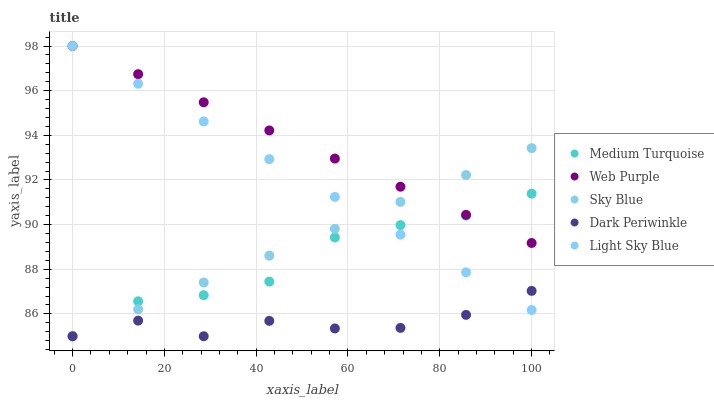Does Dark Periwinkle have the minimum area under the curve?
Answer yes or no. Yes. Does Web Purple have the maximum area under the curve?
Answer yes or no. Yes. Does Light Sky Blue have the minimum area under the curve?
Answer yes or no. No. Does Light Sky Blue have the maximum area under the curve?
Answer yes or no. No. Is Light Sky Blue the smoothest?
Answer yes or no. Yes. Is Dark Periwinkle the roughest?
Answer yes or no. Yes. Is Web Purple the smoothest?
Answer yes or no. No. Is Web Purple the roughest?
Answer yes or no. No. Does Sky Blue have the lowest value?
Answer yes or no. Yes. Does Light Sky Blue have the lowest value?
Answer yes or no. No. Does Light Sky Blue have the highest value?
Answer yes or no. Yes. Does Dark Periwinkle have the highest value?
Answer yes or no. No. Is Dark Periwinkle less than Web Purple?
Answer yes or no. Yes. Is Web Purple greater than Dark Periwinkle?
Answer yes or no. Yes. Does Light Sky Blue intersect Sky Blue?
Answer yes or no. Yes. Is Light Sky Blue less than Sky Blue?
Answer yes or no. No. Is Light Sky Blue greater than Sky Blue?
Answer yes or no. No. Does Dark Periwinkle intersect Web Purple?
Answer yes or no. No. 